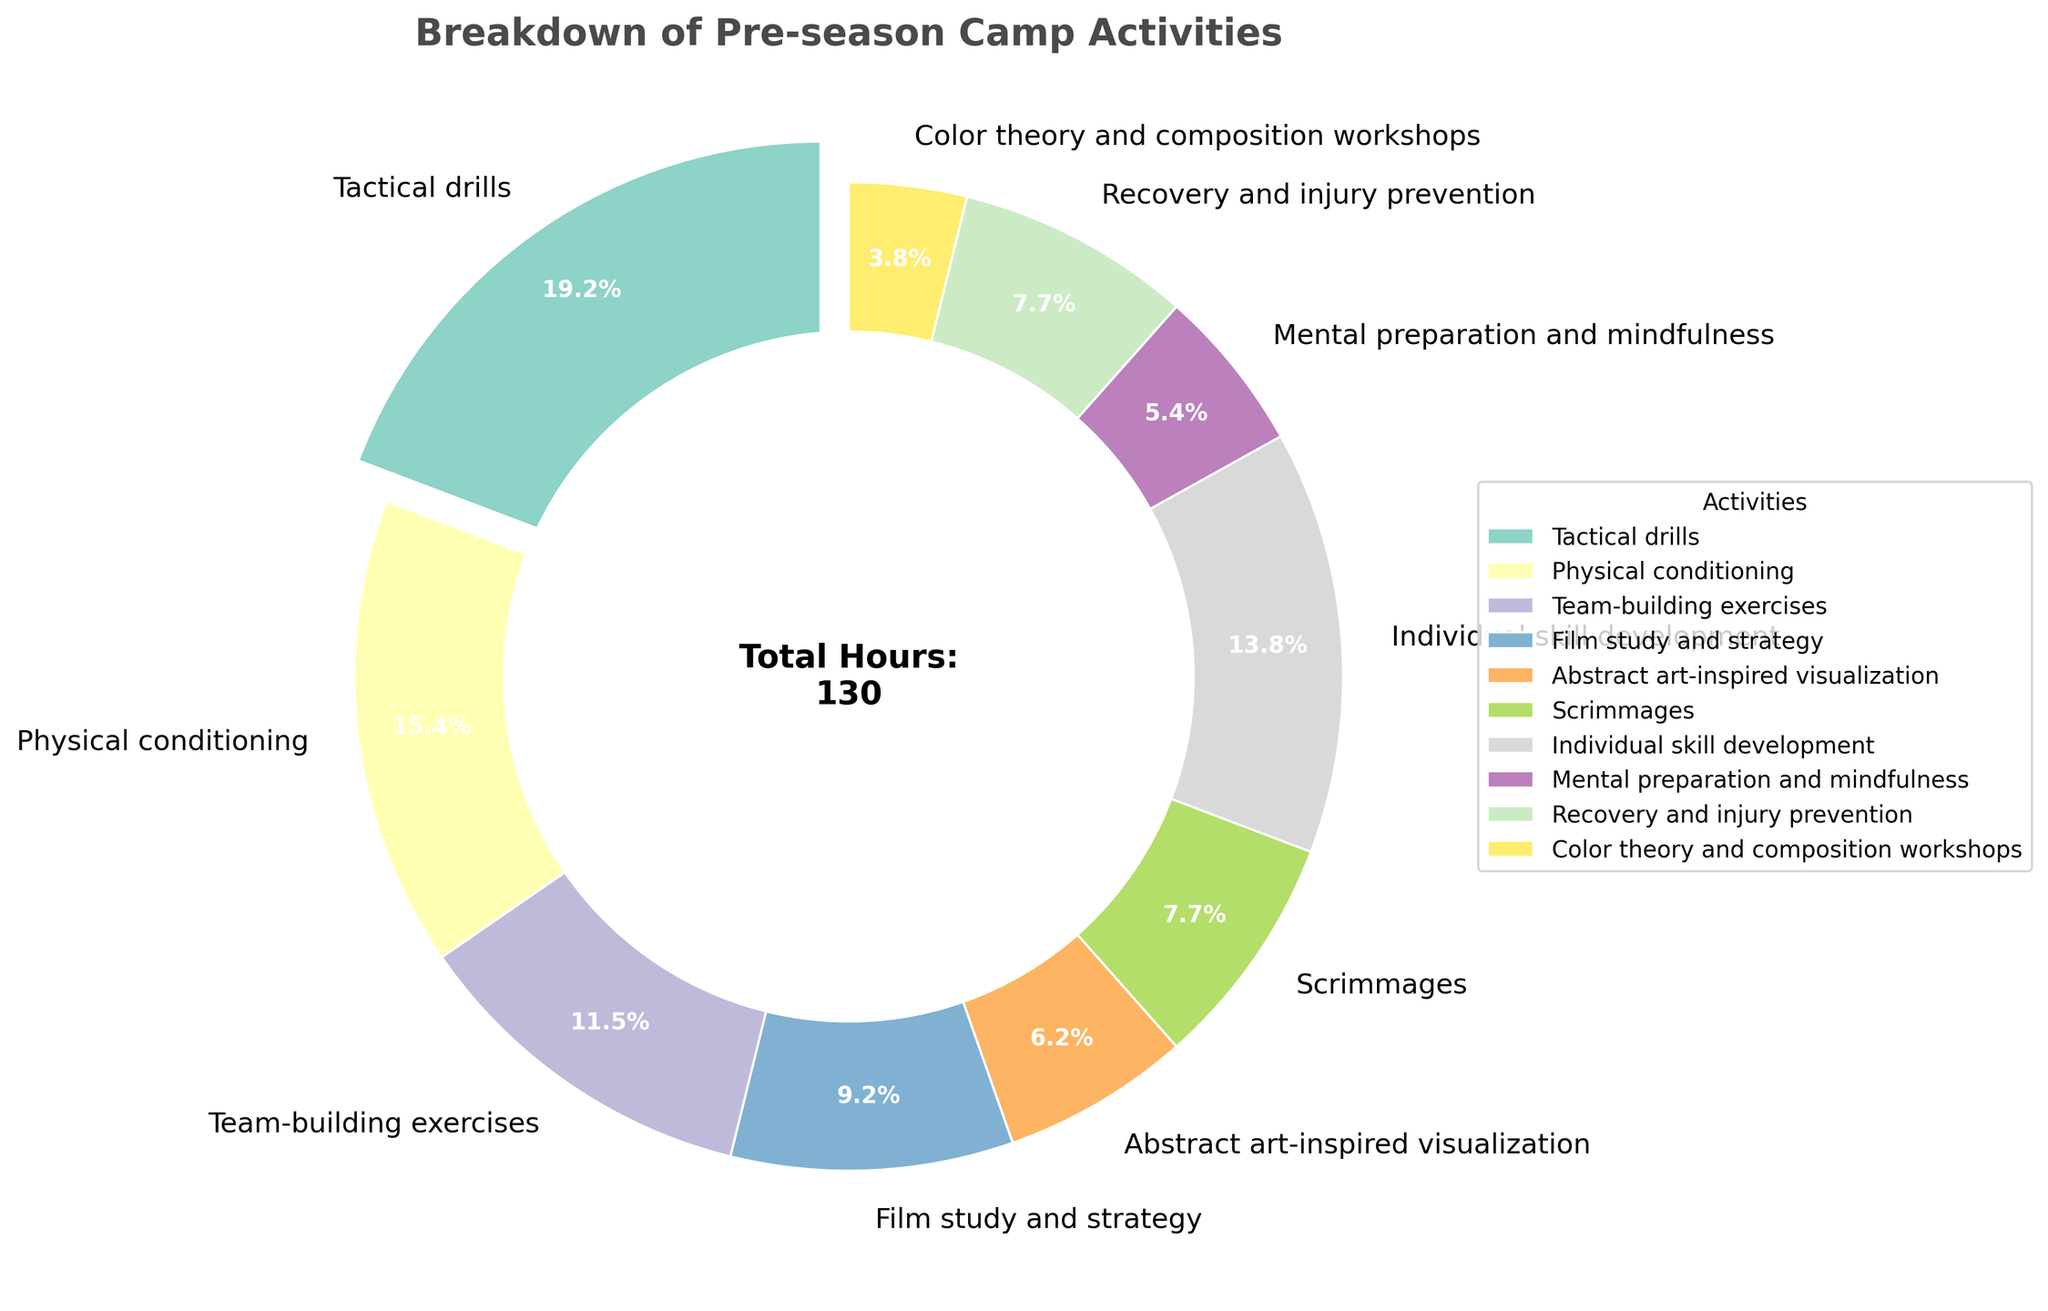what activity takes up the largest portion of time? The activity with the largest portion will be indicated by the segment with the greatest angle and may also have the largest text percentage. By examining the chart, we see that 'Tactical drills' has the largest portion at 25%.
Answer: Tactical drills What is the percentage of time spent on 'Film study and strategy'? Look at the corresponding segment labeled 'Film study and strategy' and read the percentage value displayed.
Answer: 12% What is the combined percentage of time spent on 'Scrimmages' and 'Recovery and injury prevention'? First, find the two segments for 'Scrimmages' and 'Recovery and injury prevention', then add their percentages: 10% + 10% = 20%.
Answer: 20% Which activity takes up more time: 'Mental preparation and mindfulness' or 'Color theory and composition workshops'? Compare the segments for 'Mental preparation and mindfulness' (7%) and 'Color theory and composition workshops' (5%) to see which is larger.
Answer: Mental preparation and mindfulness What is the difference in percentage between 'Physical conditioning' and 'Individual skill development'? Subtract the percentage of 'Individual skill development' from 'Physical conditioning', which is 20% - 18% = 2%.
Answer: 2% What color segment represents 'Abstract art-inspired visualization'? Identify the segment labeled 'Abstract art-inspired visualization' and note its filled color.
Answer: Red (or specify the exact color seen) How many activities take up 10% or more of the total time? Count all segments in the pie chart that have 10% or more labeled, which includes 'Tactical drills', 'Physical conditioning', 'Individual skill development', 'Scrimmages', and 'Recovery and injury prevention', summing to five activities.
Answer: 5 What is the average percentage of time spent on 'Team-building exercises' and 'Film study and strategy'? Add the two percentages for 'Team-building exercises' (15%) and 'Film study and strategy' (12%), then divide by two: (15% + 12%) / 2 = 13.5%.
Answer: 13.5% Does 'Team-building exercises' take up a greater percentage of time than 'Individual skill development'? Compare the segments for 'Team-building exercises' (15%) and 'Individual skill development' (18%) to see which is larger.
Answer: No What is the total percentage of time spent on 'Tactical drills', 'Physical conditioning', and 'Team-building exercises'? Sum the percentages for 'Tactical drills' (25%), 'Physical conditioning' (20%), and 'Team-building exercises' (15%). 25% + 20% + 15% = 60%.
Answer: 60% 